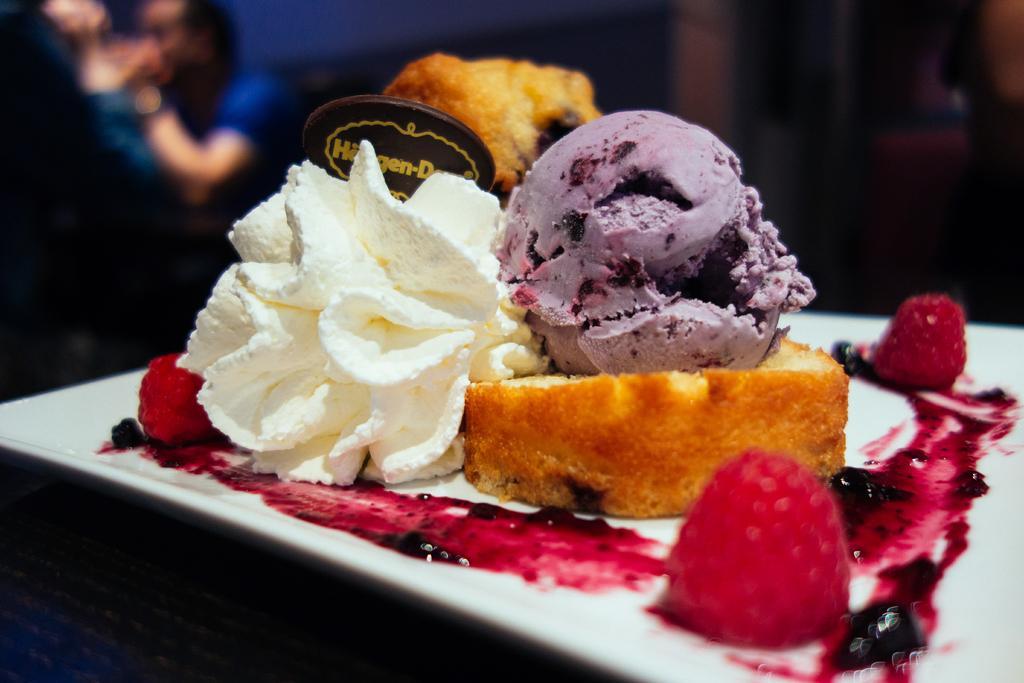Can you describe this image briefly? In this image I can see a white colour plate in the front and in it I can see different types of food. I can also see a brown colour thing on the food and on it I can see something is written. On the top left side of this image I can see a person and I can see this image is little bit blurry in the background. 